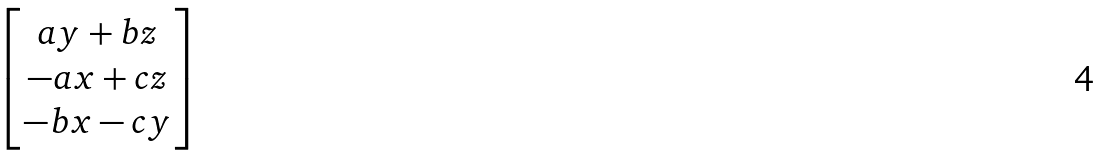Convert formula to latex. <formula><loc_0><loc_0><loc_500><loc_500>\begin{bmatrix} a y + b z \\ - a x + c z \\ - b x - c y \end{bmatrix}</formula> 